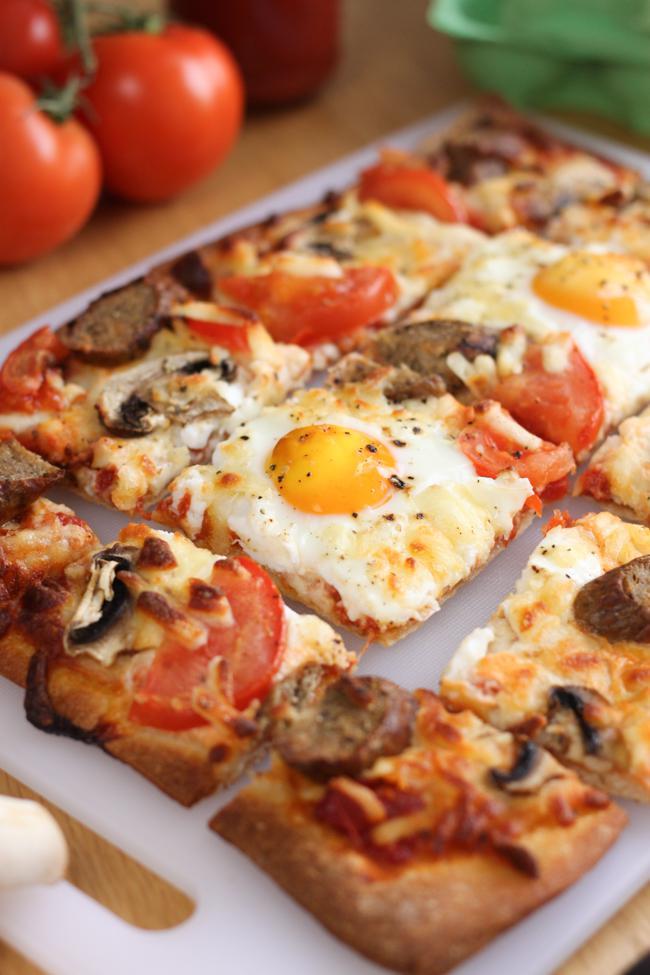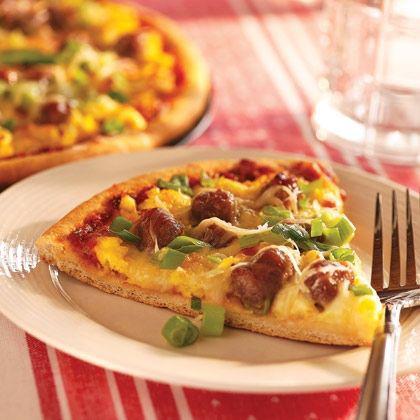The first image is the image on the left, the second image is the image on the right. Evaluate the accuracy of this statement regarding the images: "All of the pizzas have been sliced.". Is it true? Answer yes or no. Yes. The first image is the image on the left, the second image is the image on the right. Assess this claim about the two images: "The yellow yolk of an egg and pieces of tomato can be seen among the toppings on a baked pizza in one image". Correct or not? Answer yes or no. Yes. 